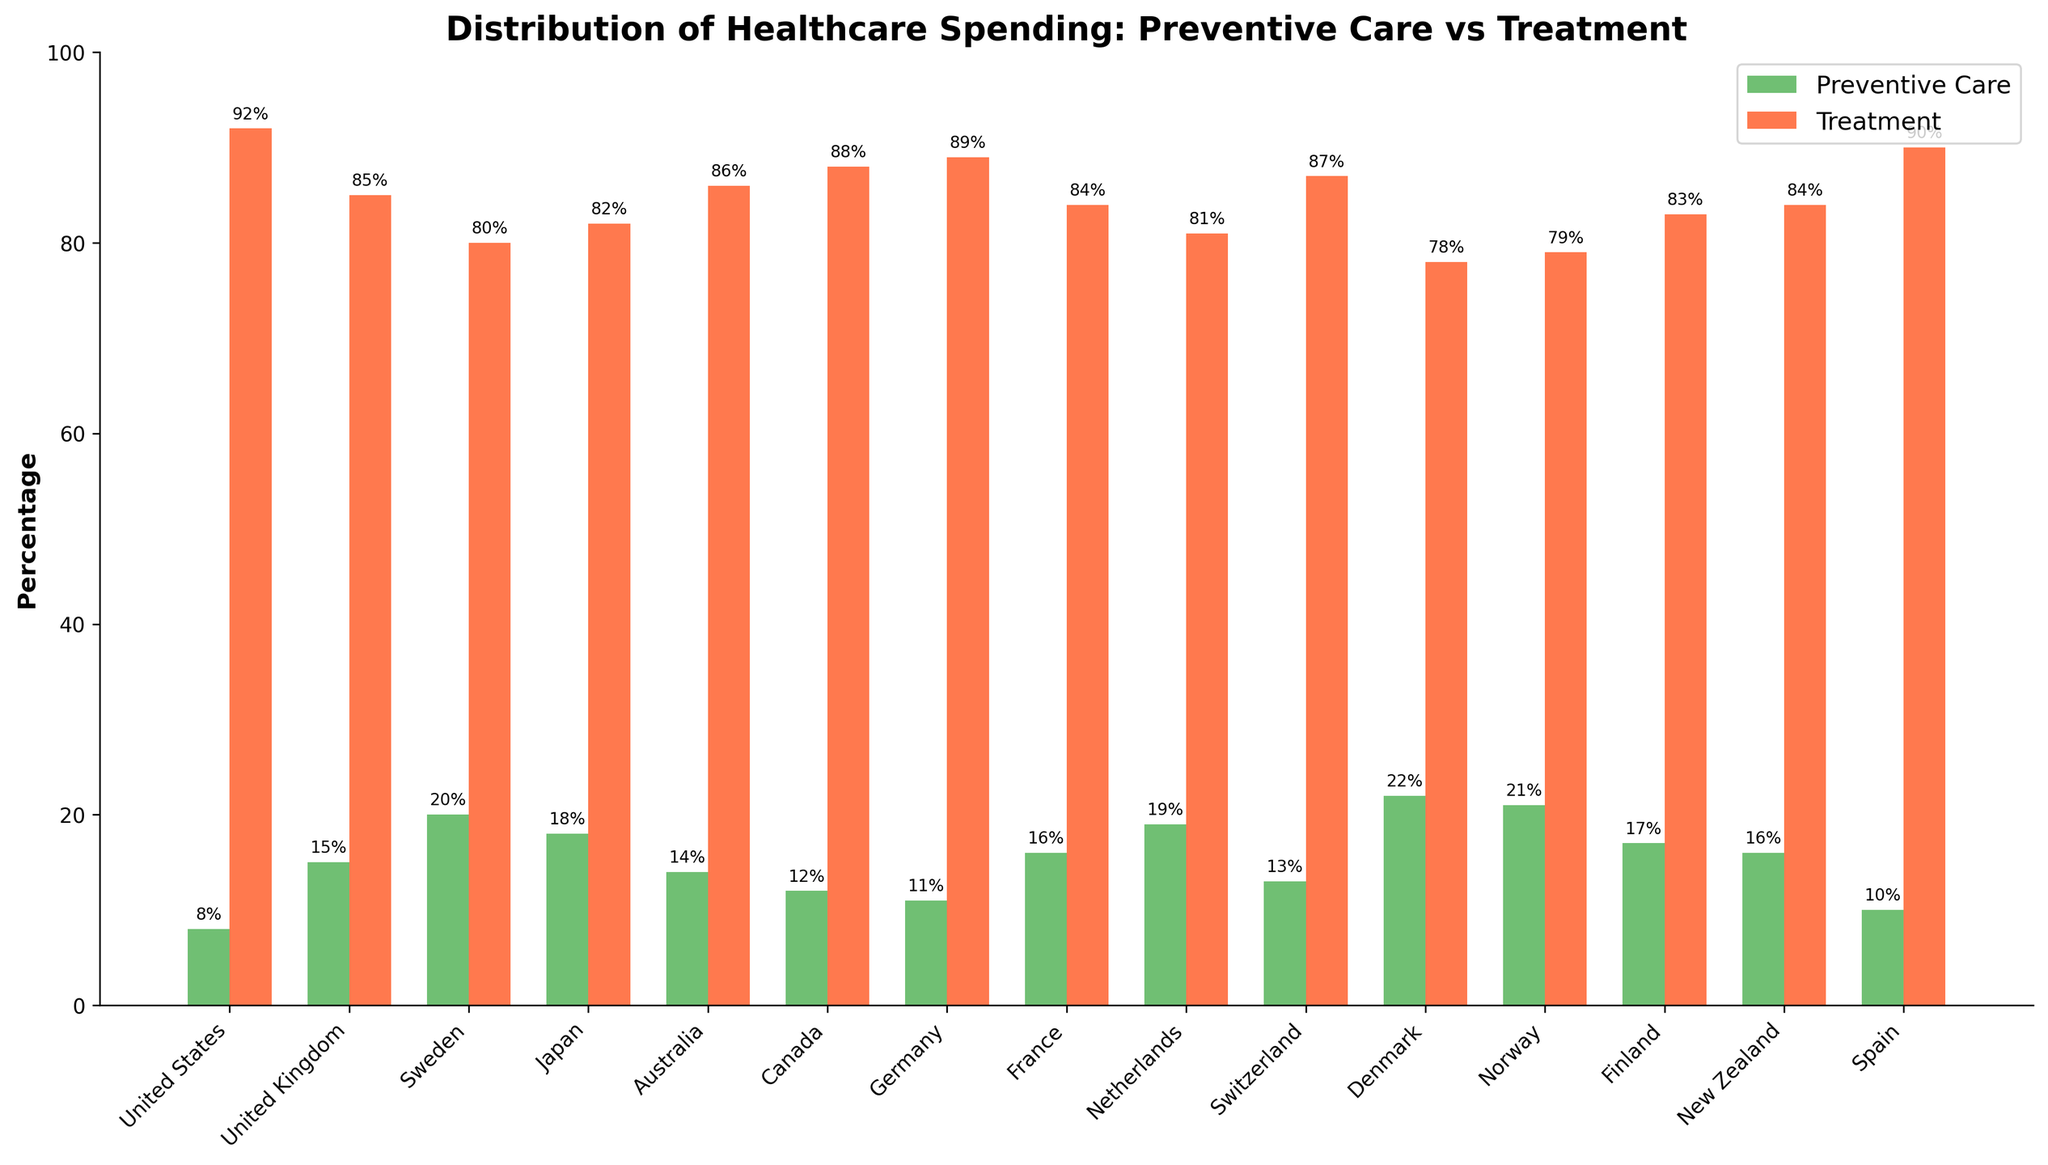What's the percentage of healthcare spending on preventive care in Denmark? Identify the bar labeled 'Denmark' and look at its height under the 'Preventive Care' category (colored green). The height of the green bar represents the percentage for preventive care.
Answer: 22% Which country allocates the highest percentage of its healthcare spending to preventive care? Compare the heights of all the green bars representing preventive care. The tallest green bar indicates the country with the highest percentage of spending on preventive care.
Answer: Denmark How much more does the United States spend on treatment compared to preventive care? In the figure, identify the percentage of spending for preventive care and treatment in the United States (green and red bars respectively). Subtract the percentage of preventive care from the percentage of treatment (92% - 8% = 84%).
Answer: 84% Which country has the smallest gap between spending on preventive care and treatment? Calculate the difference between the percentages for preventive care and treatment for each country. The country with the smallest absolute difference has the smallest gap.
Answer: Sweden What's the average percentage of spending on preventive care across all the countries? Add the percentages of preventive care for all countries and divide by the number of countries. The sum is (8 + 15 + 20 + 18 + 14 + 12 + 11 + 16 + 19 + 13 + 22 + 21 + 17 + 16 + 10) = 232, and the number of countries is 15. Therefore, the average is 232/15 ≈ 15.47
Answer: 15.47% Does any country spend an equal percentage on preventive care and treatment? Observe the figure for any country where the heights of both the green and red bars are equal. In this chart, no such situation exists.
Answer: No Which country allocates more of its healthcare spending to treatment: Canada or France? Compare the heights of the red bars labeled 'Canada' and 'France'. The taller red bar indicates the higher spending on treatment.
Answer: Canada What is the combined spending percentage of preventive care for Norway and New Zealand? Add the percentages for preventive care for Norway (21%) and New Zealand (16%). The combined spending is 21% + 16% = 37%.
Answer: 37% How does healthcare spending on treatment compare between Spain and Germany? Compare the heights of the red bars labeled 'Spain' and 'Germany'. The taller red bar indicates higher spending on treatment.
Answer: Spain What is the total percentage of healthcare spending for preventive care and treatment in Japan? Add the percentages for preventive care and treatment in Japan (18% + 82%). The total is 100%, which confirms all healthcare spending categories are covered.
Answer: 100% 